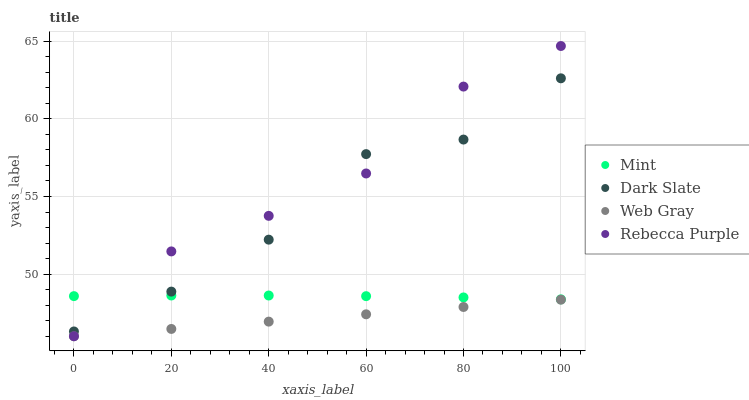Does Web Gray have the minimum area under the curve?
Answer yes or no. Yes. Does Rebecca Purple have the maximum area under the curve?
Answer yes or no. Yes. Does Mint have the minimum area under the curve?
Answer yes or no. No. Does Mint have the maximum area under the curve?
Answer yes or no. No. Is Web Gray the smoothest?
Answer yes or no. Yes. Is Dark Slate the roughest?
Answer yes or no. Yes. Is Mint the smoothest?
Answer yes or no. No. Is Mint the roughest?
Answer yes or no. No. Does Web Gray have the lowest value?
Answer yes or no. Yes. Does Mint have the lowest value?
Answer yes or no. No. Does Rebecca Purple have the highest value?
Answer yes or no. Yes. Does Mint have the highest value?
Answer yes or no. No. Is Web Gray less than Mint?
Answer yes or no. Yes. Is Dark Slate greater than Web Gray?
Answer yes or no. Yes. Does Web Gray intersect Rebecca Purple?
Answer yes or no. Yes. Is Web Gray less than Rebecca Purple?
Answer yes or no. No. Is Web Gray greater than Rebecca Purple?
Answer yes or no. No. Does Web Gray intersect Mint?
Answer yes or no. No. 